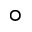<formula> <loc_0><loc_0><loc_500><loc_500>^ { \circ }</formula> 